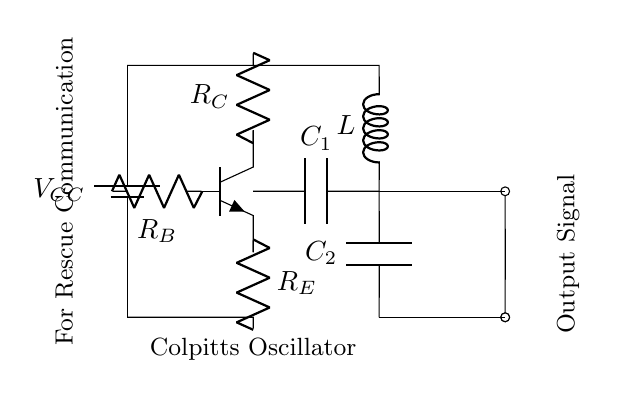What is the type of transistor used in this circuit? The circuit uses an NPN transistor, which is identifiable by the symbol drawn on the diagram. This is indicated by the three terminals (collector, base, and emitter) and the arrangement of the arrows in the symbol.
Answer: NPN What is the value of the resistor connected to the collector? The value of the resistor connected to the collector is labeled as R_C in the circuit diagram. Since the question is about the visual aspect, R_C represents its designation rather than a numerical value.
Answer: R_C What is the purpose of the capacitors in this oscillator circuit? The capacitors, labeled C_1 and C_2, serve to determine the frequency of oscillation in a Colpitts oscillator. They are part of the feedback network which controls the timing of oscillation.
Answer: Frequency control How does the output signal get generated in this circuit? The output signal is generated from the oscillations produced by the transistor's amplification of the signal formed through the feedback from the capacitors and inductor. The output is taken across a node connected to the feedback loop.
Answer: Through amplification What component types are used for frequency selection in this circuit? The frequency selection in a Colpitts oscillator is primarily determined by the capacitors (C_1 and C_2) and the inductor (L). Their values dictate the resonant frequency of the oscillator circuit.
Answer: Capacitors and inductor What is the arrangement of the components in relation to the transistor? The components are arranged such that the collector is connected to the output via the resistor R_C, the base receives biasing through R_B, and the emitter is connected through R_E. Capacitors and inductor form the feedback loop, providing the necessary elements for oscillation.
Answer: Feedback loop 